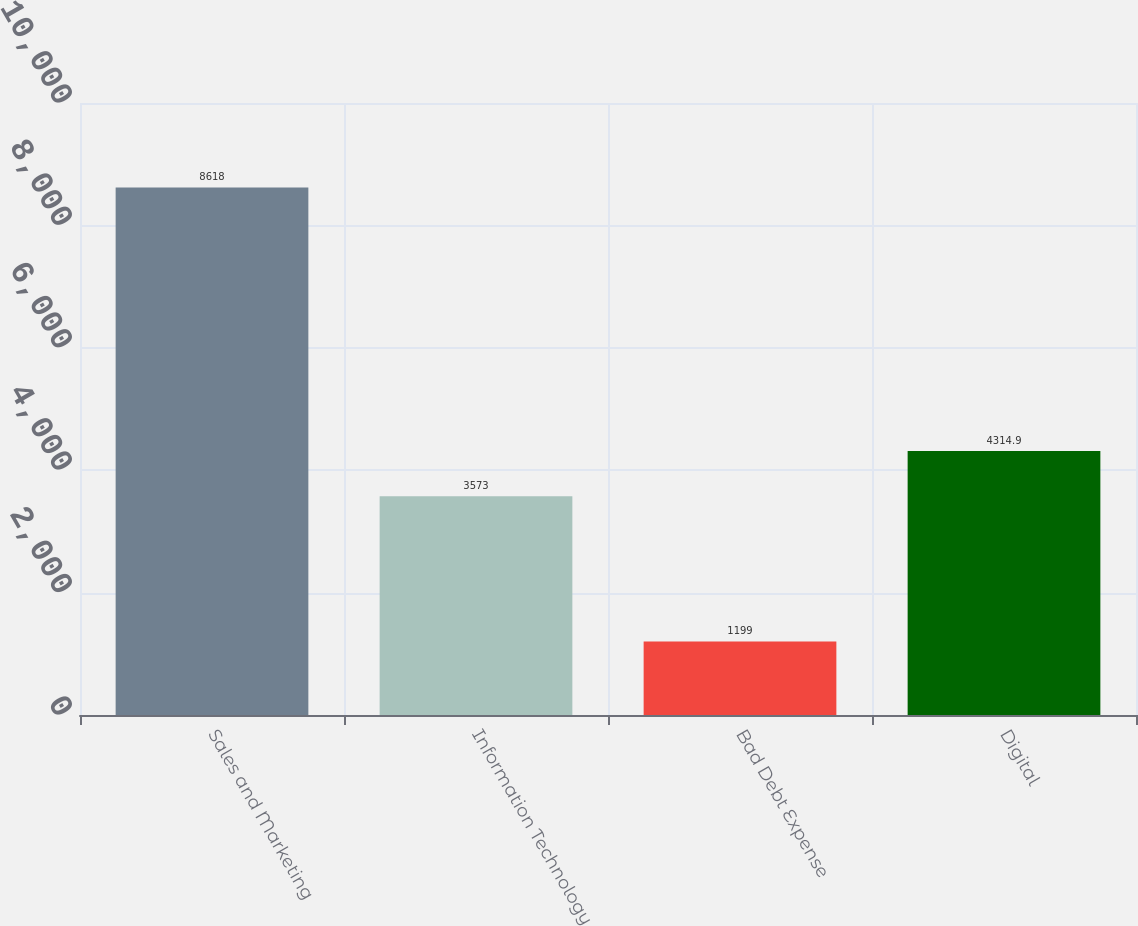<chart> <loc_0><loc_0><loc_500><loc_500><bar_chart><fcel>Sales and Marketing<fcel>Information Technology<fcel>Bad Debt Expense<fcel>Digital<nl><fcel>8618<fcel>3573<fcel>1199<fcel>4314.9<nl></chart> 